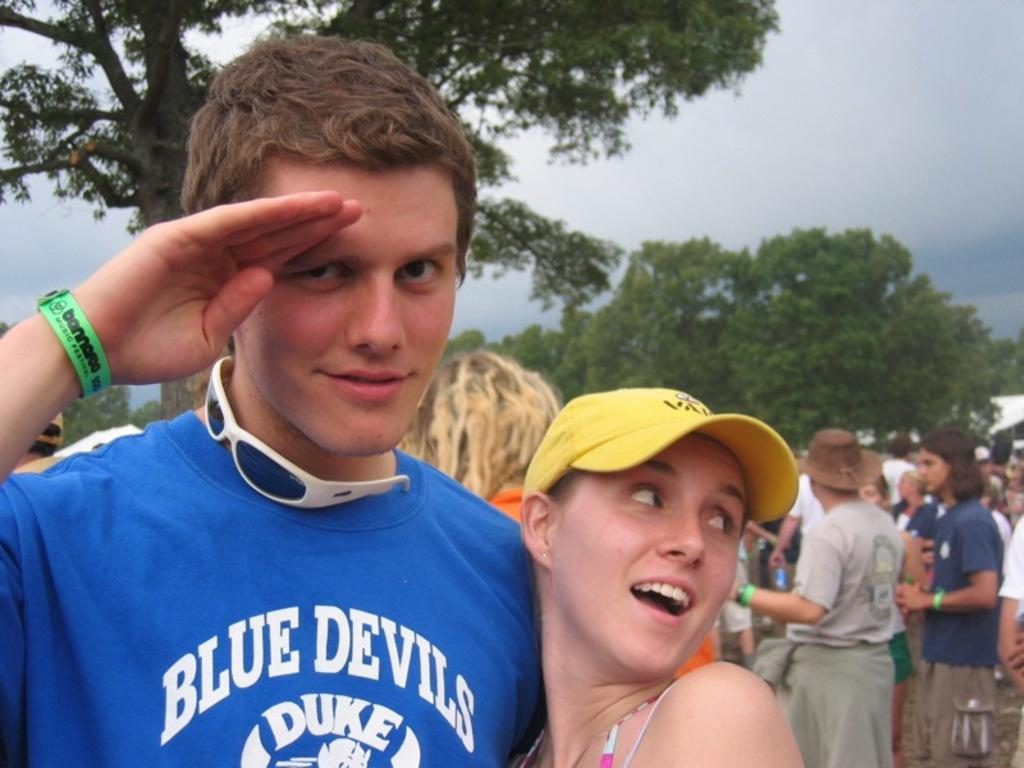Who are the two people standing in the image? There is a man and a woman standing in the image. What is the man doing in the image? The man is saluting. How many people are standing in the image? There is a group of people standing in the image. What type of vegetation can be seen in the image? There are trees with branches and leaves in the image. What color is the paint used to create the title of the image? There is no paint or title present in the image. 